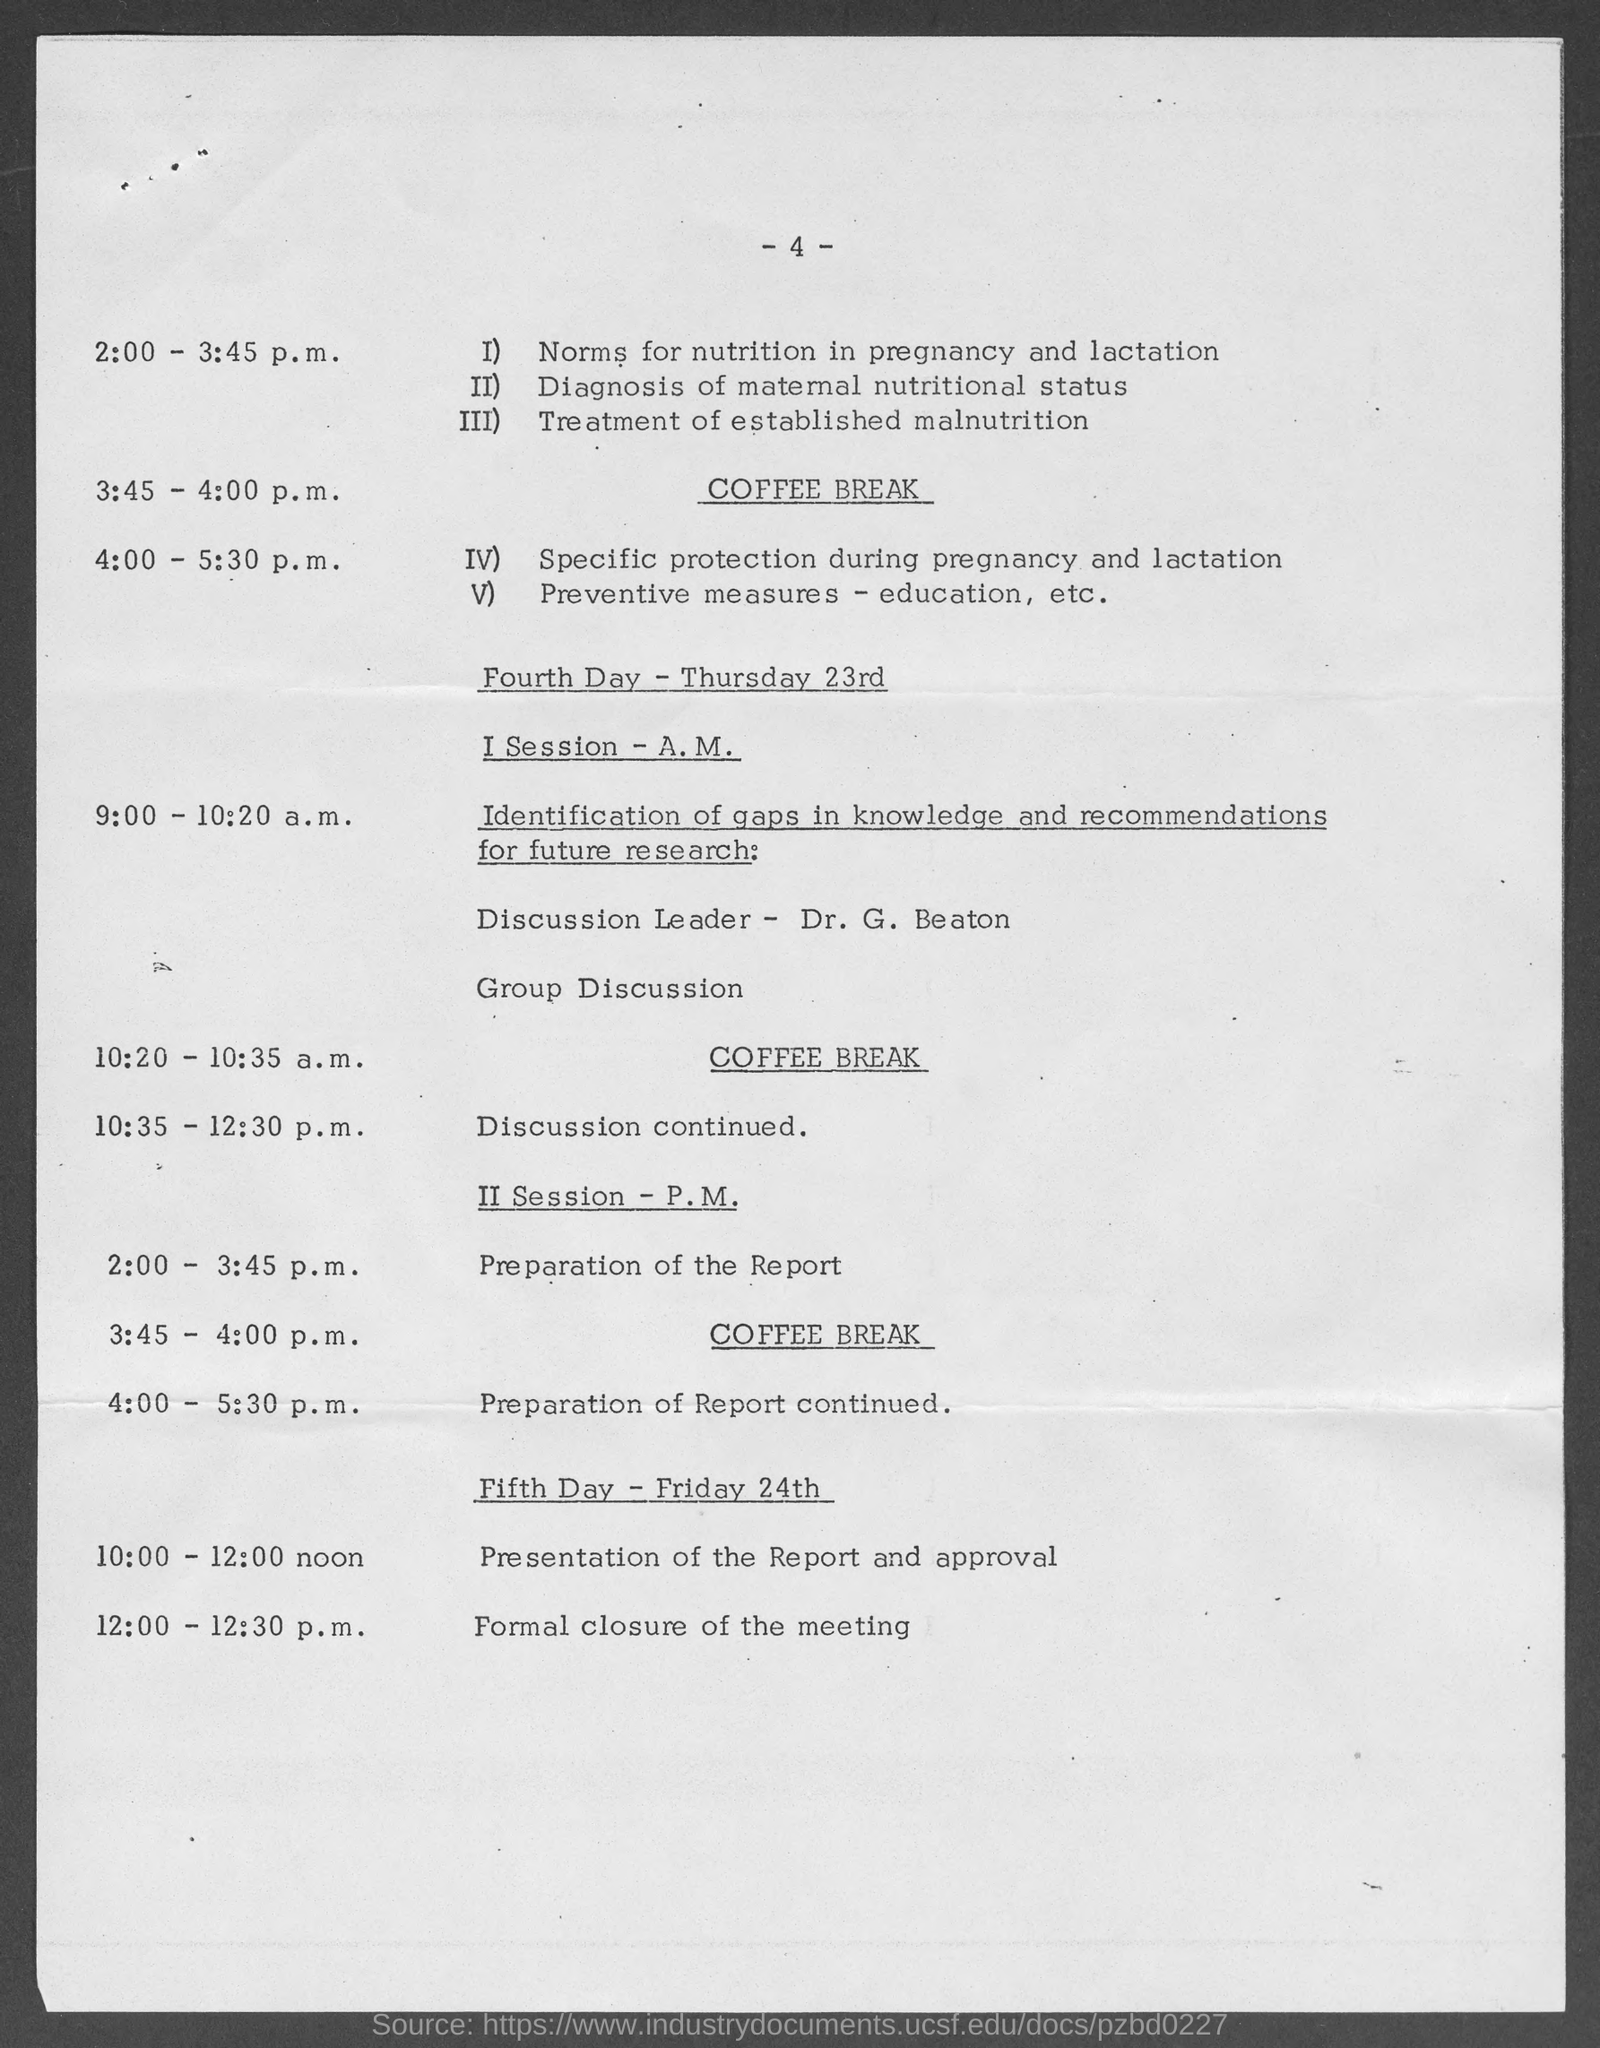What is the Page Number?
Ensure brevity in your answer.  -4-. 